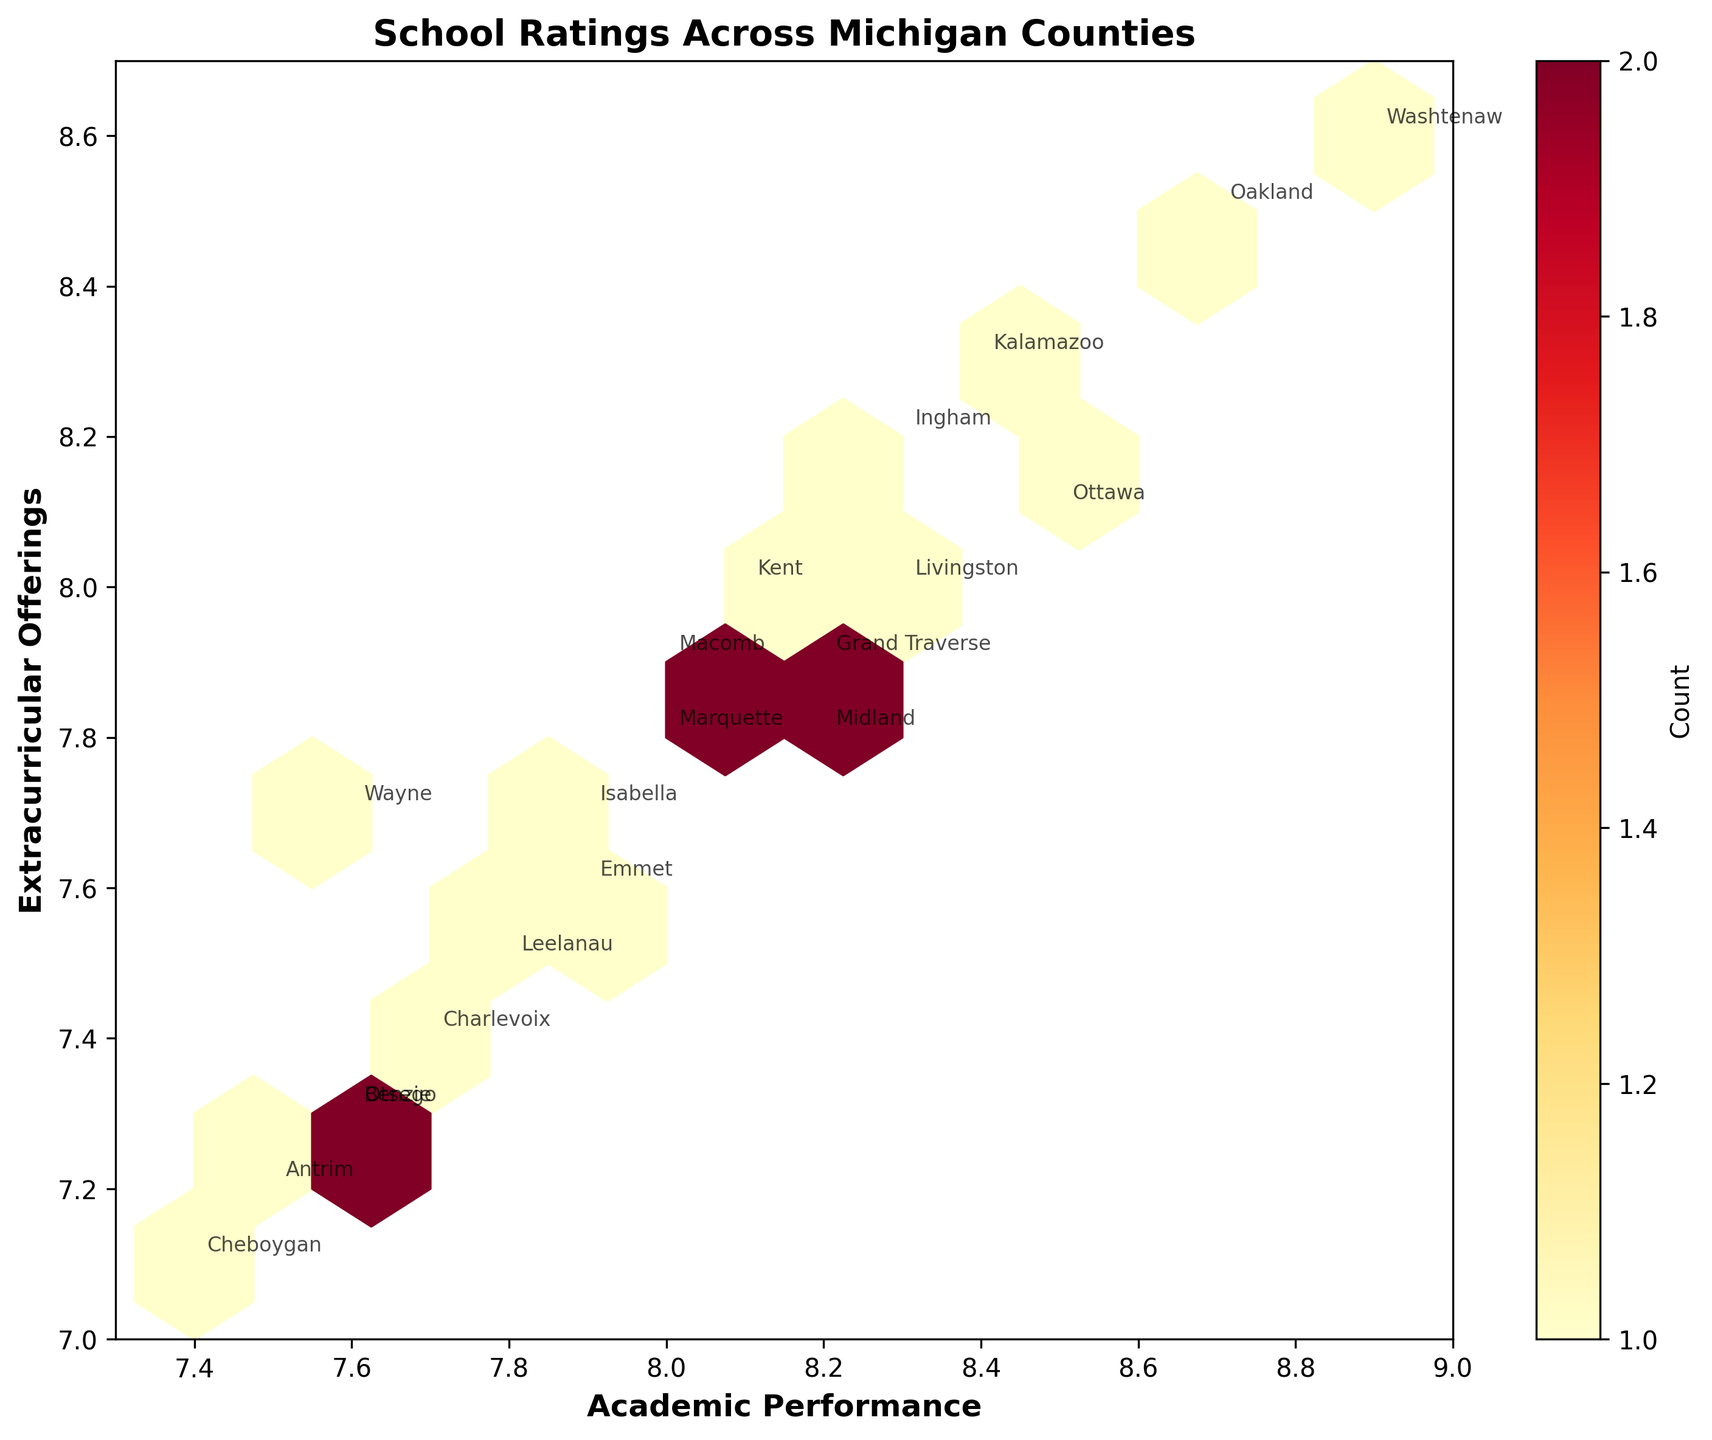What is the title of the figure? The title is displayed prominently at the top of the figure. It helps to understand the general content of the plot.
Answer: School Ratings Across Michigan Counties Which county has the highest academic performance? Look at the x-axis (academic performance) and find the data point farthest to the right. The county name is annotated next to that point.
Answer: Washtenaw How many counties have academic performance below 8.0? Examine the x-axis values and count the counties whose academic performance is below 8.0. Annotated county names help in identification.
Answer: 7 Which county has the highest extracurricular offerings? Look at the y-axis (extracurricular offerings) and find the data point highest on this axis. The county name is annotated next to that point.
Answer: Washtenaw What is the color of the hexagons in the figure and what does it represent? Observe the color scheme of the hexagons. The color scale (YlOrRd) represents the density or count of data points in each hexbin. The figure's colorbar further explicates this.
Answer: Shades of yellow to red representing data point density Which two counties have nearly identical academic performance and extracurricular offerings? Identify data points that are very close to each other both on the x-axis and y-axis. Annotated county names help in identifying them.
Answer: Grand Traverse and Midland What is the median value of academic performance among the counties? Arrange all academic performance values in ascending order and find the middle value. From the data, the median academic performance is the middle value of the sorted list. Detailed math: (7.4, 7.5, 7.6, 7.6, 7.6, 7.7, 7.8, 7.9, 7.9, 8.0, 8.0, 8.1, 8.2, 8.2, 8.3, 8.3, 8.4, 8.5, 8.7, 8.9) - the middle value is (8.0 + 8.0)/2 = 8.0.
Answer: 8.0 Which county has both the lowest academic performance and lowest extracurricular offerings? Find the data point closest to the bottom-left corner (lowest values on both axes). The county name is annotated near this point.
Answer: Cheboygan Are there any counties with higher extracurricular offerings than academic performance? Compare y-axis values to x-axis values for all data points. Annotated county names help to find such counties. None has a higher y value than x value.
Answer: No Which county has the largest difference between academic performance and extracurricular offerings? Calculate the difference between academic performance and extracurricular offerings for each county and identify the one with the largest difference. Cheboygan has 7.4 (performance) - 7.1 (offerings) = 0.3.
Answer: Cheboygan 